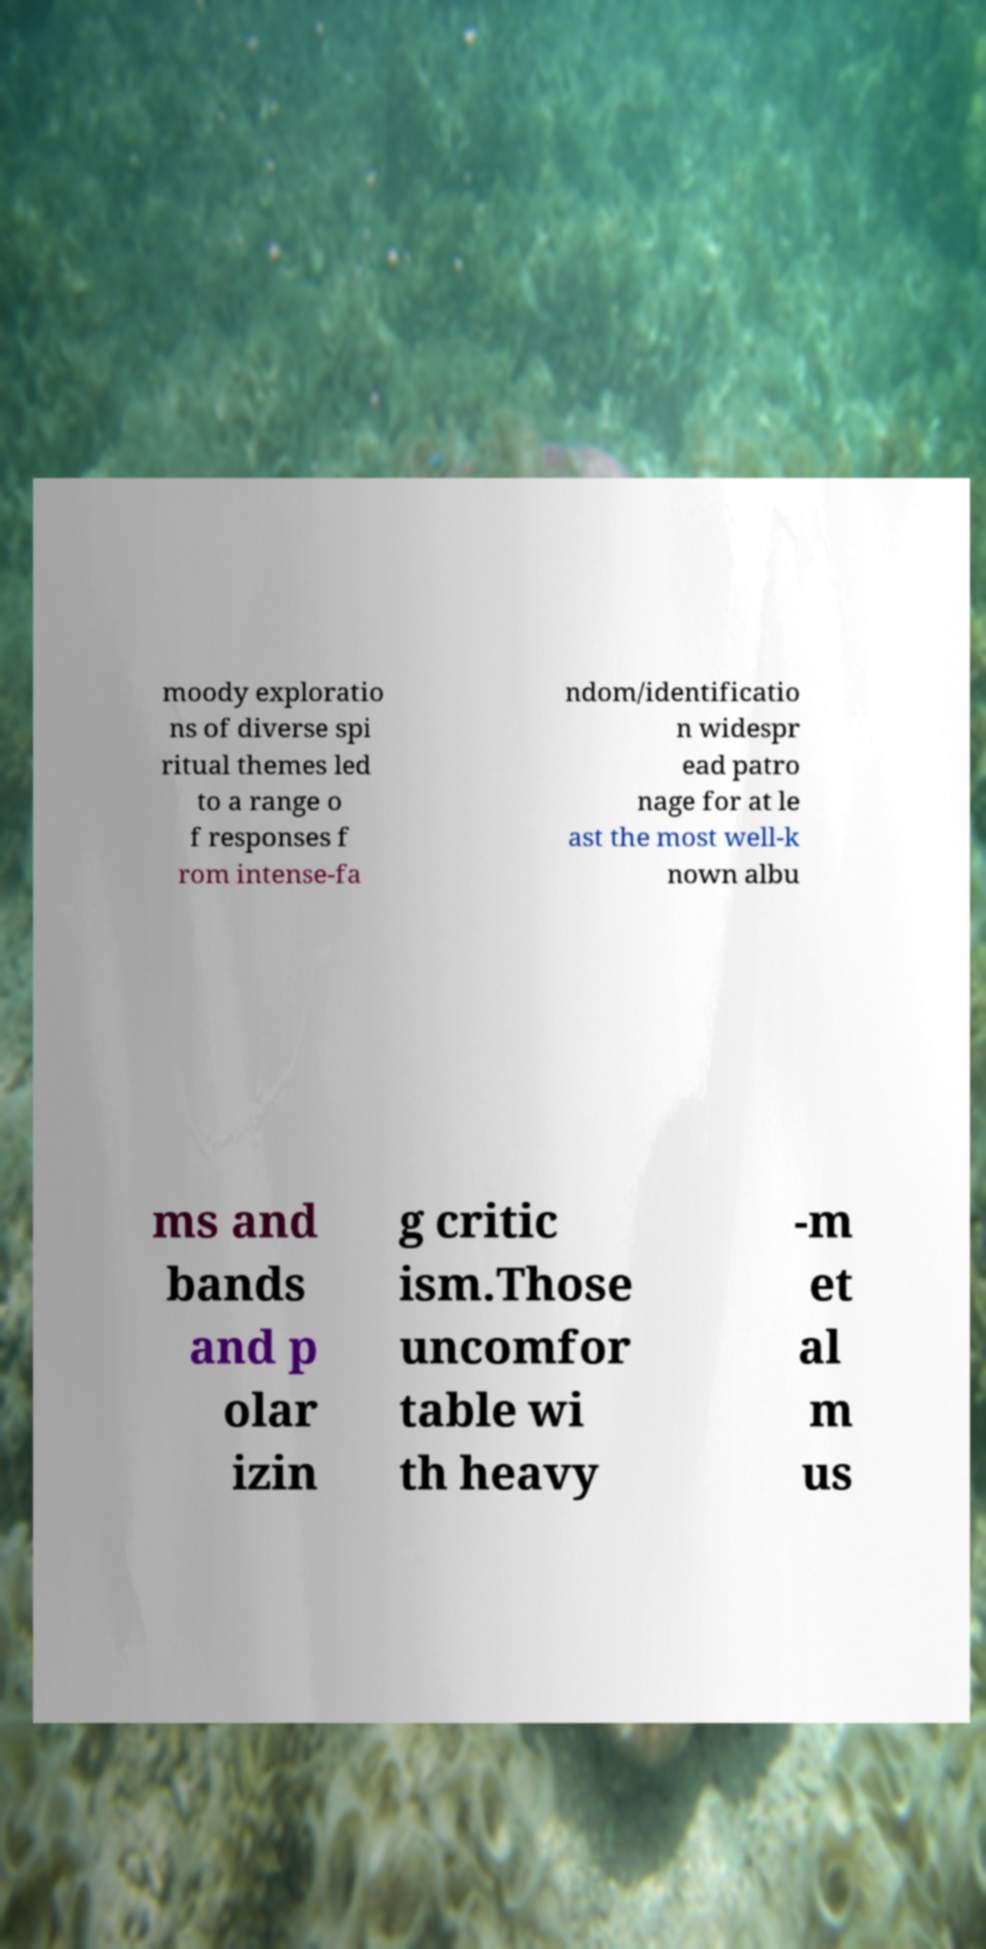For documentation purposes, I need the text within this image transcribed. Could you provide that? moody exploratio ns of diverse spi ritual themes led to a range o f responses f rom intense-fa ndom/identificatio n widespr ead patro nage for at le ast the most well-k nown albu ms and bands and p olar izin g critic ism.Those uncomfor table wi th heavy -m et al m us 